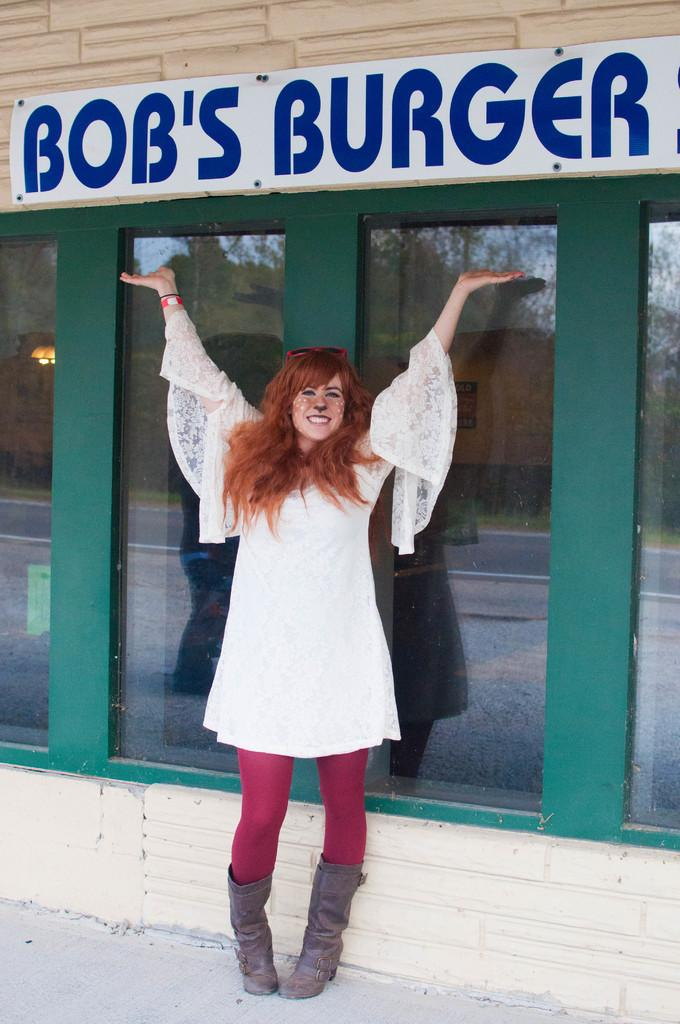What is the woman in the image doing? The woman is standing and smiling in the image. What object can be seen in the woman's hand? There is a glass in the image. What is on the wall in the image? There is a board on a wall in the image. What can be seen through the glass in the image? Trees, a road, a wall, and the sky are visible through the glass. What type of beef can be seen hanging from the board in the image? There is no beef present in the image; the board on the wall does not have any meat hanging from it. 